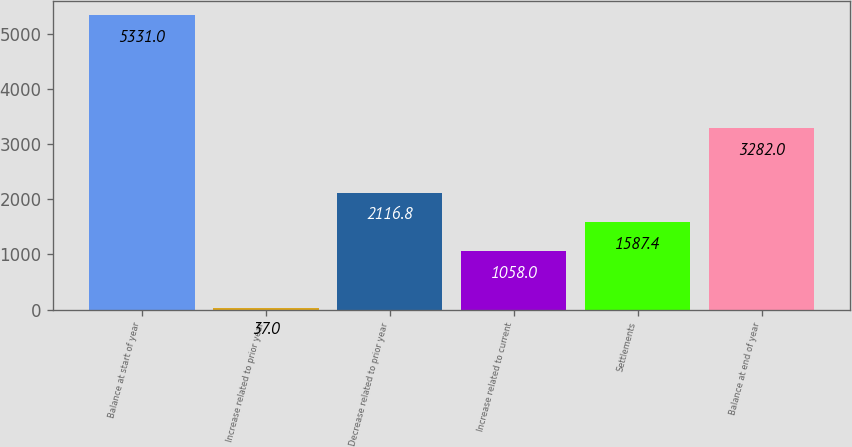Convert chart. <chart><loc_0><loc_0><loc_500><loc_500><bar_chart><fcel>Balance at start of year<fcel>Increase related to prior year<fcel>Decrease related to prior year<fcel>Increase related to current<fcel>Settlements<fcel>Balance at end of year<nl><fcel>5331<fcel>37<fcel>2116.8<fcel>1058<fcel>1587.4<fcel>3282<nl></chart> 